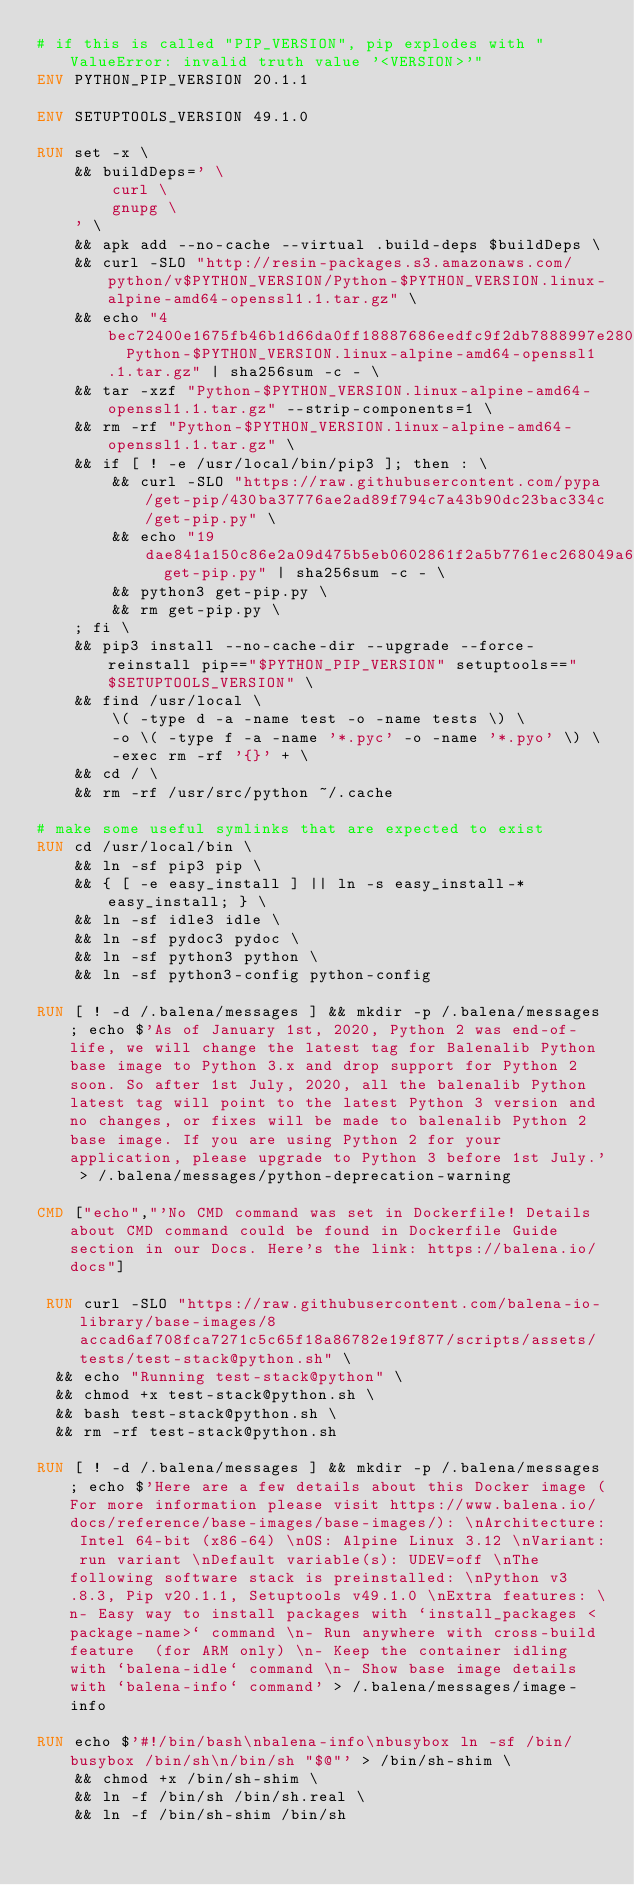Convert code to text. <code><loc_0><loc_0><loc_500><loc_500><_Dockerfile_># if this is called "PIP_VERSION", pip explodes with "ValueError: invalid truth value '<VERSION>'"
ENV PYTHON_PIP_VERSION 20.1.1

ENV SETUPTOOLS_VERSION 49.1.0

RUN set -x \
	&& buildDeps=' \
		curl \
		gnupg \
	' \
	&& apk add --no-cache --virtual .build-deps $buildDeps \
	&& curl -SLO "http://resin-packages.s3.amazonaws.com/python/v$PYTHON_VERSION/Python-$PYTHON_VERSION.linux-alpine-amd64-openssl1.1.tar.gz" \
	&& echo "4bec72400e1675fb46b1d66da0ff18887686eedfc9f2db7888997e2806e4c087  Python-$PYTHON_VERSION.linux-alpine-amd64-openssl1.1.tar.gz" | sha256sum -c - \
	&& tar -xzf "Python-$PYTHON_VERSION.linux-alpine-amd64-openssl1.1.tar.gz" --strip-components=1 \
	&& rm -rf "Python-$PYTHON_VERSION.linux-alpine-amd64-openssl1.1.tar.gz" \
	&& if [ ! -e /usr/local/bin/pip3 ]; then : \
		&& curl -SLO "https://raw.githubusercontent.com/pypa/get-pip/430ba37776ae2ad89f794c7a43b90dc23bac334c/get-pip.py" \
		&& echo "19dae841a150c86e2a09d475b5eb0602861f2a5b7761ec268049a662dbd2bd0c  get-pip.py" | sha256sum -c - \
		&& python3 get-pip.py \
		&& rm get-pip.py \
	; fi \
	&& pip3 install --no-cache-dir --upgrade --force-reinstall pip=="$PYTHON_PIP_VERSION" setuptools=="$SETUPTOOLS_VERSION" \
	&& find /usr/local \
		\( -type d -a -name test -o -name tests \) \
		-o \( -type f -a -name '*.pyc' -o -name '*.pyo' \) \
		-exec rm -rf '{}' + \
	&& cd / \
	&& rm -rf /usr/src/python ~/.cache

# make some useful symlinks that are expected to exist
RUN cd /usr/local/bin \
	&& ln -sf pip3 pip \
	&& { [ -e easy_install ] || ln -s easy_install-* easy_install; } \
	&& ln -sf idle3 idle \
	&& ln -sf pydoc3 pydoc \
	&& ln -sf python3 python \
	&& ln -sf python3-config python-config

RUN [ ! -d /.balena/messages ] && mkdir -p /.balena/messages; echo $'As of January 1st, 2020, Python 2 was end-of-life, we will change the latest tag for Balenalib Python base image to Python 3.x and drop support for Python 2 soon. So after 1st July, 2020, all the balenalib Python latest tag will point to the latest Python 3 version and no changes, or fixes will be made to balenalib Python 2 base image. If you are using Python 2 for your application, please upgrade to Python 3 before 1st July.' > /.balena/messages/python-deprecation-warning

CMD ["echo","'No CMD command was set in Dockerfile! Details about CMD command could be found in Dockerfile Guide section in our Docs. Here's the link: https://balena.io/docs"]

 RUN curl -SLO "https://raw.githubusercontent.com/balena-io-library/base-images/8accad6af708fca7271c5c65f18a86782e19f877/scripts/assets/tests/test-stack@python.sh" \
  && echo "Running test-stack@python" \
  && chmod +x test-stack@python.sh \
  && bash test-stack@python.sh \
  && rm -rf test-stack@python.sh 

RUN [ ! -d /.balena/messages ] && mkdir -p /.balena/messages; echo $'Here are a few details about this Docker image (For more information please visit https://www.balena.io/docs/reference/base-images/base-images/): \nArchitecture: Intel 64-bit (x86-64) \nOS: Alpine Linux 3.12 \nVariant: run variant \nDefault variable(s): UDEV=off \nThe following software stack is preinstalled: \nPython v3.8.3, Pip v20.1.1, Setuptools v49.1.0 \nExtra features: \n- Easy way to install packages with `install_packages <package-name>` command \n- Run anywhere with cross-build feature  (for ARM only) \n- Keep the container idling with `balena-idle` command \n- Show base image details with `balena-info` command' > /.balena/messages/image-info

RUN echo $'#!/bin/bash\nbalena-info\nbusybox ln -sf /bin/busybox /bin/sh\n/bin/sh "$@"' > /bin/sh-shim \
	&& chmod +x /bin/sh-shim \
	&& ln -f /bin/sh /bin/sh.real \
	&& ln -f /bin/sh-shim /bin/sh</code> 